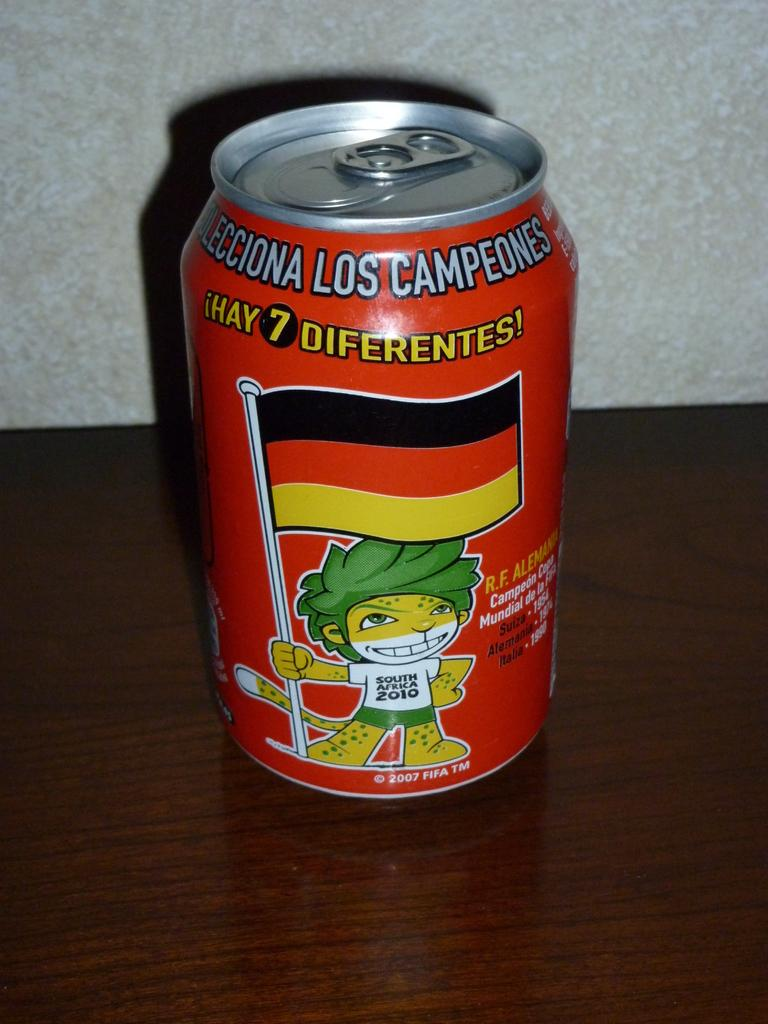<image>
Write a terse but informative summary of the picture. A can of drink with the word Diferentes on it. 